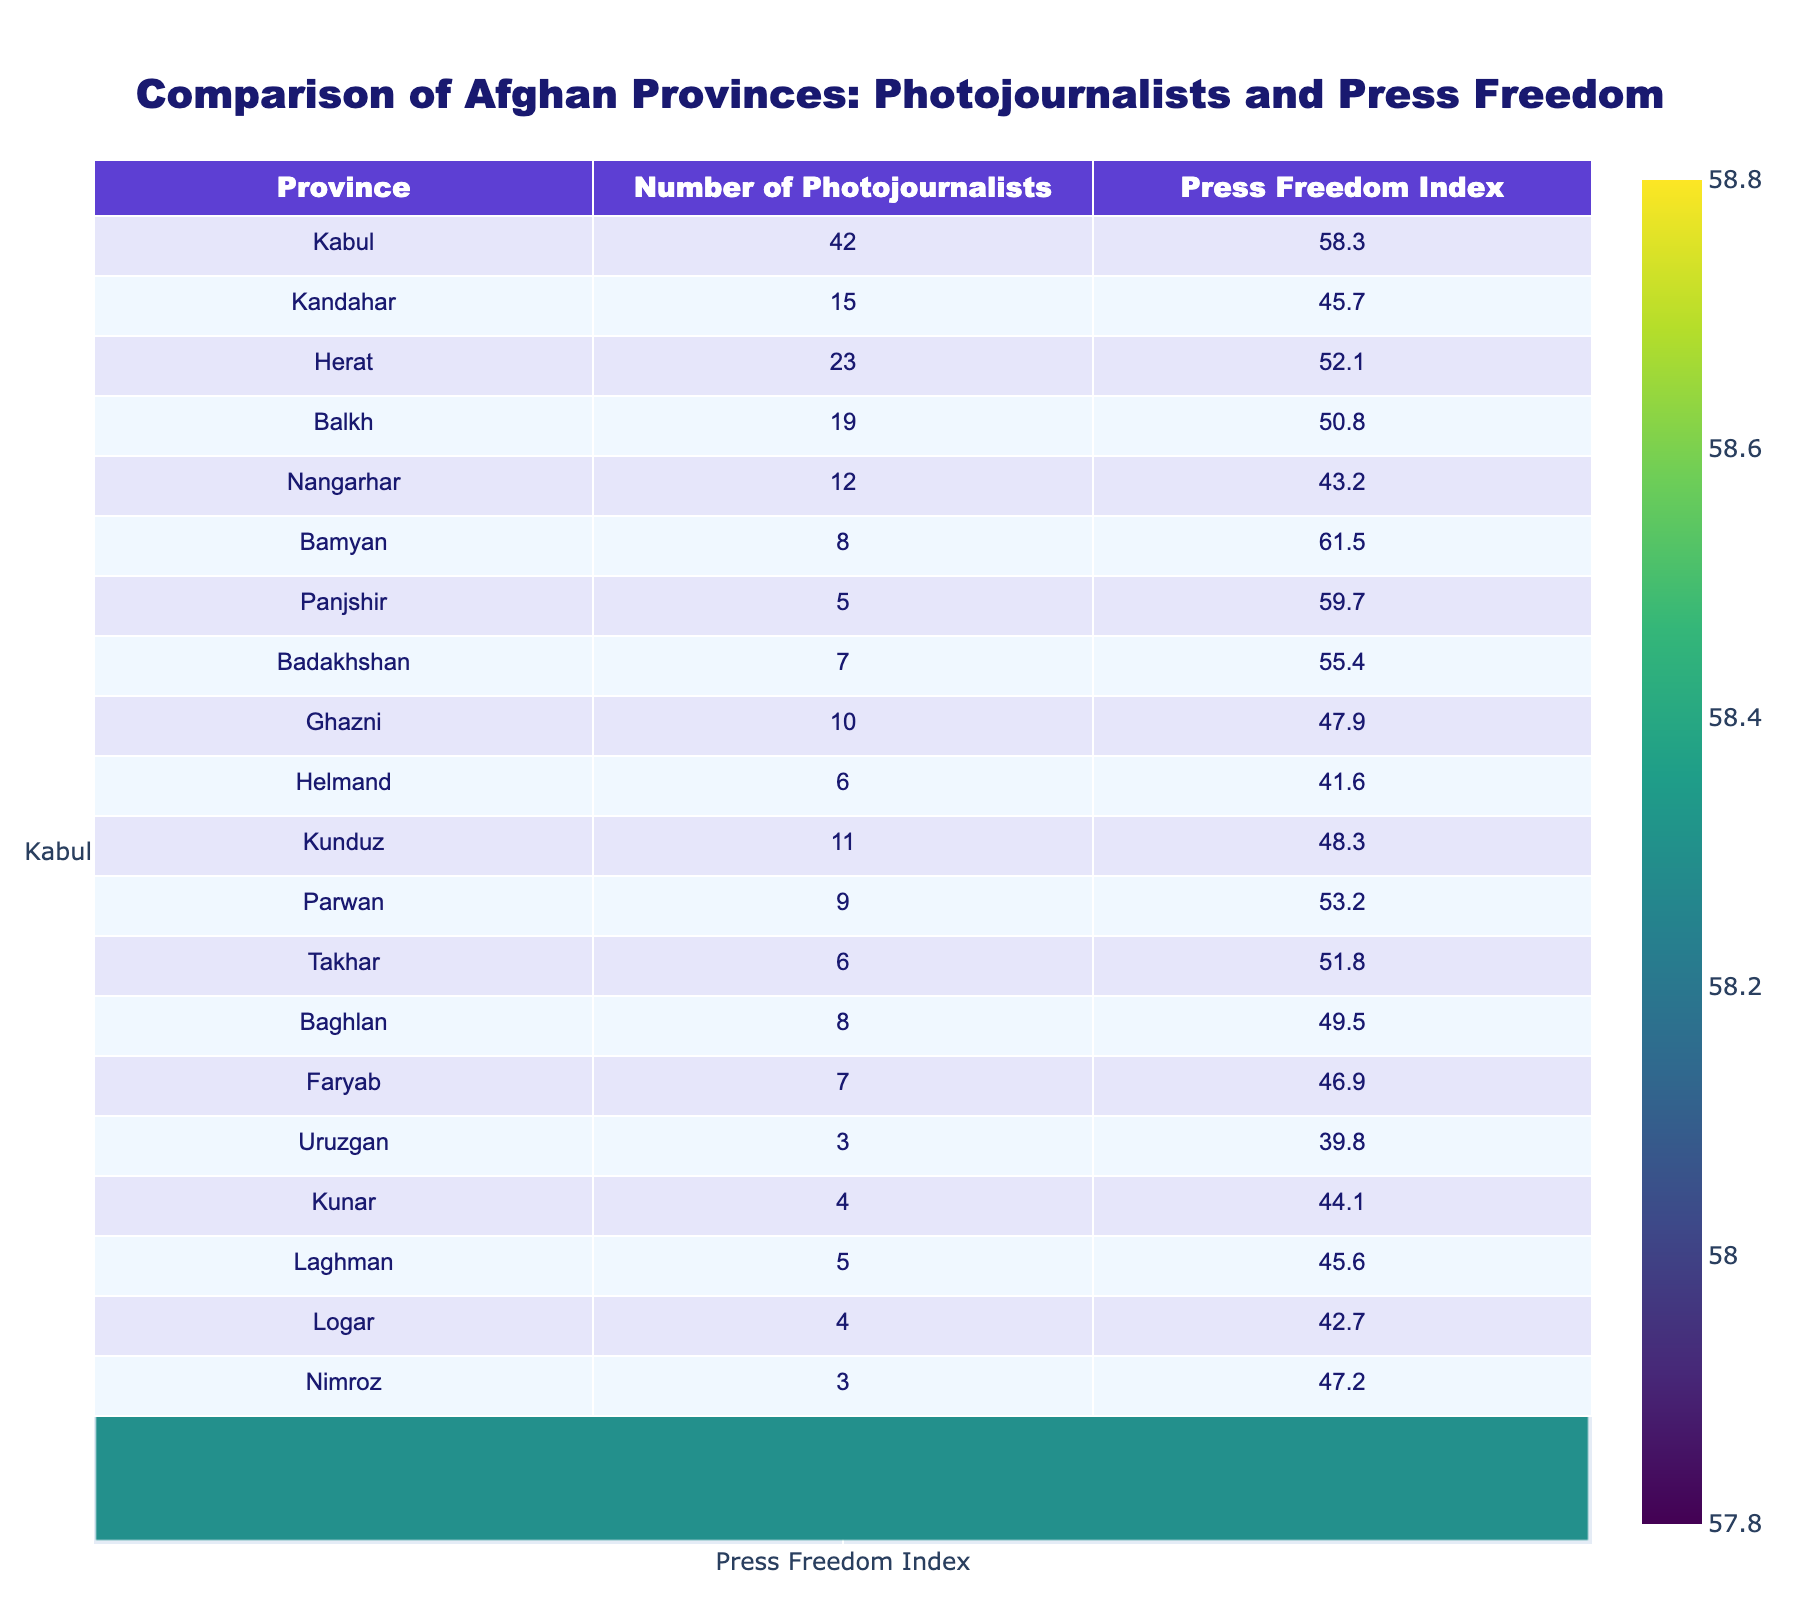What is the province with the highest number of photojournalists? By looking at the table, Kabul has the highest count of photojournalists at 42.
Answer: Kabul Which province has the lowest press freedom index? The table indicates that Uruzgan has the lowest press freedom index at 39.8.
Answer: Uruzgan How many photojournalists are there in Kandahar? The table shows that there are 15 photojournalists in Kandahar.
Answer: 15 What is the average press freedom index of all provinces? Adding the press freedom indices (58.3 + 45.7 + 52.1 + 50.8 + 43.2 + 61.5 + 59.7 + 55.4 + 47.9 + 41.6 + 48.3 + 53.2 + 51.8 + 49.5 + 46.9 + 39.8 + 44.1 + 45.6 + 42.7 + 47.2) gives a total of 925.8, divided by the number of provinces (20) results in an average of 46.29.
Answer: 46.29 Which provinces have a press freedom index above 50? Referring to the table, the provinces with a press freedom index above 50 are Bamyan (61.5), Kabul (58.3), and Panjshir (59.7).
Answer: Bamyan, Kabul, Panjshir How many provinces have more than 10 photojournalists? The provinces with more than 10 photojournalists are Kabul (42), Kandahar (15), Herat (23), Balkh (19), Kunduz (11), making a total of 5 provinces.
Answer: 5 Is there a correlation between the number of photojournalists and the press freedom index? While the table suggests that Kabul, with the highest number of photojournalists, has a relatively high press freedom index, other provinces like Kandahar don't follow this trend. Analysis shows that while there is a positive trend (more photojournalists in higher press freedom areas), it is not consistent across all provinces, indicating correlation but not causation.
Answer: Yes, but with exceptions What is the difference between the highest and lowest press freedom index? The highest press freedom index is 61.5 (Bamyan) and the lowest is 39.8 (Uruzgan). The difference is 61.5 - 39.8 = 21.7.
Answer: 21.7 Name three provinces that have fewer than 10 photojournalists. According to the table, the provinces with fewer than 10 photojournalists are Bamyan (8), Panjshir (5), and Uruzgan (3).
Answer: Bamyan, Panjshir, Uruzgan What percentage of the provinces have a press freedom index below 50? Five provinces have a press freedom index below 50 out of 20 provinces, so the percentage is (5/20) * 100 = 25%.
Answer: 25% Which province has the closest number of photojournalists to the median of the group? Arranging the number of photojournalists gives a median number around 8.5 (10 is the middle of the ordered list). The province with 9 photojournalists (Parwan) is closest to the median.
Answer: Parwan 